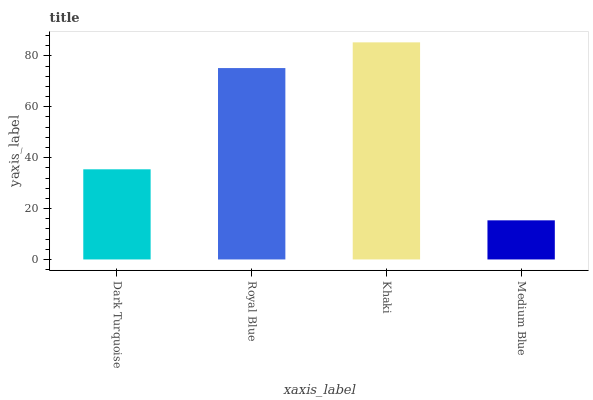Is Medium Blue the minimum?
Answer yes or no. Yes. Is Khaki the maximum?
Answer yes or no. Yes. Is Royal Blue the minimum?
Answer yes or no. No. Is Royal Blue the maximum?
Answer yes or no. No. Is Royal Blue greater than Dark Turquoise?
Answer yes or no. Yes. Is Dark Turquoise less than Royal Blue?
Answer yes or no. Yes. Is Dark Turquoise greater than Royal Blue?
Answer yes or no. No. Is Royal Blue less than Dark Turquoise?
Answer yes or no. No. Is Royal Blue the high median?
Answer yes or no. Yes. Is Dark Turquoise the low median?
Answer yes or no. Yes. Is Medium Blue the high median?
Answer yes or no. No. Is Khaki the low median?
Answer yes or no. No. 